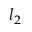Convert formula to latex. <formula><loc_0><loc_0><loc_500><loc_500>l _ { 2 }</formula> 